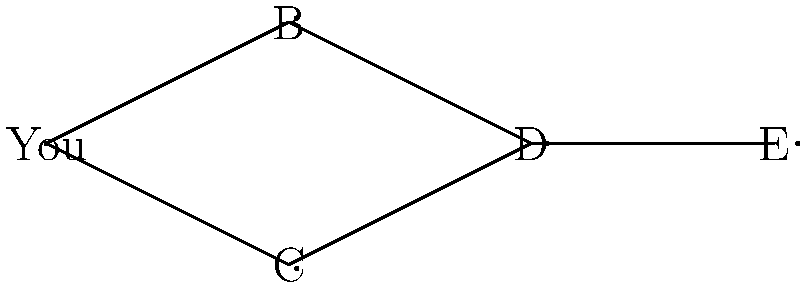In your band's collaboration network, each node represents a musician, and edges represent direct collaborations. You've been asked to organize a special performance that includes all band members. However, to maintain the flow, each musician can only directly communicate with those they've collaborated with before. What's the minimum number of times you need to pass a message to ensure it reaches all band members? To solve this problem, we need to find the eccentricity of the node representing "You" in the graph. The eccentricity is the maximum distance from a node to any other node in the graph. Here's how we can determine this:

1. First, let's find the shortest path from "You" to each other node:
   - You to B: 1 step
   - You to C: 1 step
   - You to D: 2 steps (You → B → D or You → C → D)
   - You to E: 3 steps (You → B → D → E or You → C → D → E)

2. The longest of these shortest paths is the path from You to E, which takes 3 steps.

3. This means that the eccentricity of the "You" node is 3.

4. In terms of message passing, this eccentricity represents the minimum number of times a message needs to be passed to reach the farthest node (E in this case) from "You".

Therefore, to ensure the message reaches all band members, it needs to be passed a minimum of 3 times.
Answer: 3 times 